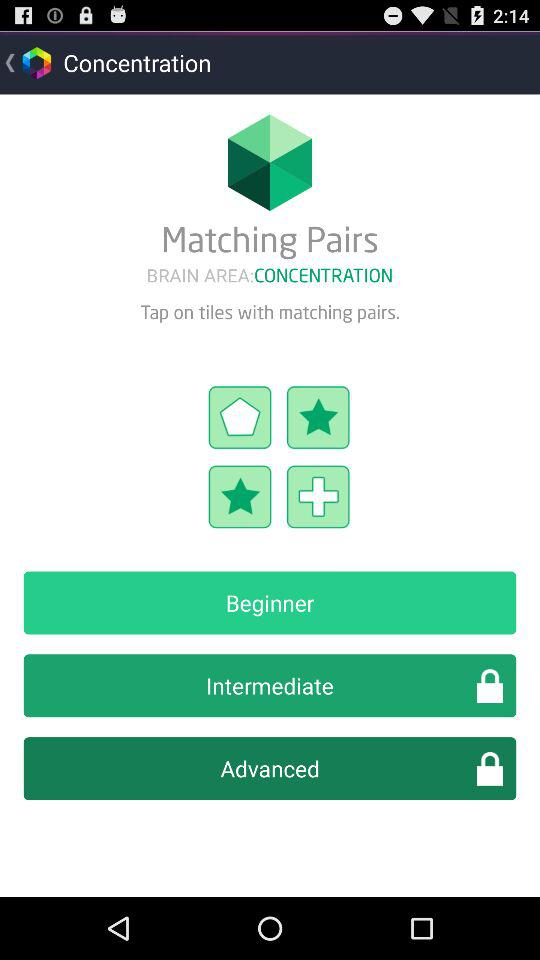How much time is allowed to tap on tiles with matching pairs?
When the provided information is insufficient, respond with <no answer>. <no answer> 